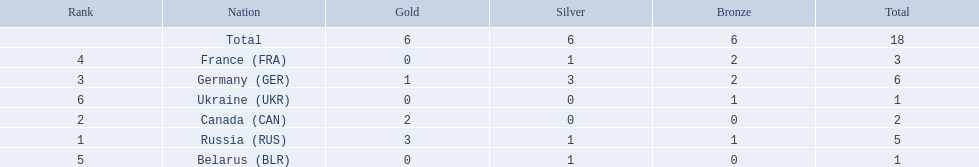Which nations participated? Russia (RUS), Canada (CAN), Germany (GER), France (FRA), Belarus (BLR), Ukraine (UKR). And how many gold medals did they win? 3, 2, 1, 0, 0, 0. What about silver medals? 1, 0, 3, 1, 1, 0. And bronze? 1, 0, 2, 2, 0, 1. Which nation only won gold medals? Canada (CAN). 